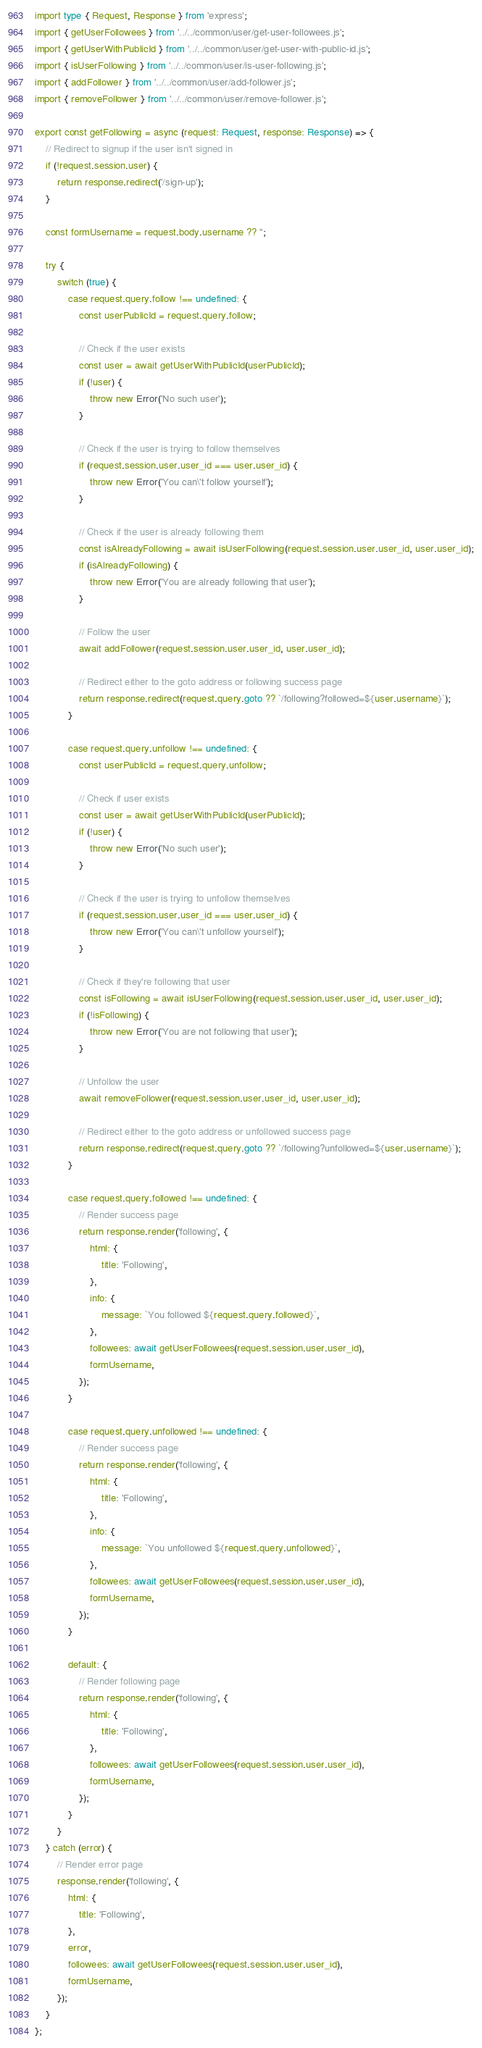<code> <loc_0><loc_0><loc_500><loc_500><_TypeScript_>import type { Request, Response } from 'express';
import { getUserFollowees } from '../../common/user/get-user-followees.js';
import { getUserWithPublicId } from '../../common/user/get-user-with-public-id.js';
import { isUserFollowing } from '../../common/user/is-user-following.js';
import { addFollower } from '../../common/user/add-follower.js';
import { removeFollower } from '../../common/user/remove-follower.js';

export const getFollowing = async (request: Request, response: Response) => {
	// Redirect to signup if the user isn't signed in
	if (!request.session.user) {
		return response.redirect('/sign-up');
	}

	const formUsername = request.body.username ?? '';

	try {
		switch (true) {
			case request.query.follow !== undefined: {
				const userPublicId = request.query.follow;

				// Check if the user exists
				const user = await getUserWithPublicId(userPublicId);
				if (!user) {
					throw new Error('No such user');
				}

				// Check if the user is trying to follow themselves
				if (request.session.user.user_id === user.user_id) {
					throw new Error('You can\'t follow yourself');
				}

				// Check if the user is already following them
				const isAlreadyFollowing = await isUserFollowing(request.session.user.user_id, user.user_id);
				if (isAlreadyFollowing) {
					throw new Error('You are already following that user');
				}

				// Follow the user
				await addFollower(request.session.user.user_id, user.user_id);

				// Redirect either to the goto address or following success page
				return response.redirect(request.query.goto ?? `/following?followed=${user.username}`);
			}

			case request.query.unfollow !== undefined: {
				const userPublicId = request.query.unfollow;

				// Check if user exists
				const user = await getUserWithPublicId(userPublicId);
				if (!user) {
					throw new Error('No such user');
				}

				// Check if the user is trying to unfollow themselves
				if (request.session.user.user_id === user.user_id) {
					throw new Error('You can\'t unfollow yourself');
				}

				// Check if they're following that user
				const isFollowing = await isUserFollowing(request.session.user.user_id, user.user_id);
				if (!isFollowing) {
					throw new Error('You are not following that user');
				}

				// Unfollow the user
				await removeFollower(request.session.user.user_id, user.user_id);

				// Redirect either to the goto address or unfollowed success page
				return response.redirect(request.query.goto ?? `/following?unfollowed=${user.username}`);
			}

			case request.query.followed !== undefined: {
				// Render success page
				return response.render('following', {
					html: {
						title: 'Following',
					},
					info: {
						message: `You followed ${request.query.followed}`,
					},
					followees: await getUserFollowees(request.session.user.user_id),
					formUsername,
				});
			}

			case request.query.unfollowed !== undefined: {
				// Render success page
				return response.render('following', {
					html: {
						title: 'Following',
					},
					info: {
						message: `You unfollowed ${request.query.unfollowed}`,
					},
					followees: await getUserFollowees(request.session.user.user_id),
					formUsername,
				});
			}

			default: {
				// Render following page
				return response.render('following', {
					html: {
						title: 'Following',
					},
					followees: await getUserFollowees(request.session.user.user_id),
					formUsername,
				});
			}
		}
	} catch (error) {
		// Render error page
		response.render('following', {
			html: {
				title: 'Following',
			},
			error,
			followees: await getUserFollowees(request.session.user.user_id),
			formUsername,
		});
	}
};
</code> 